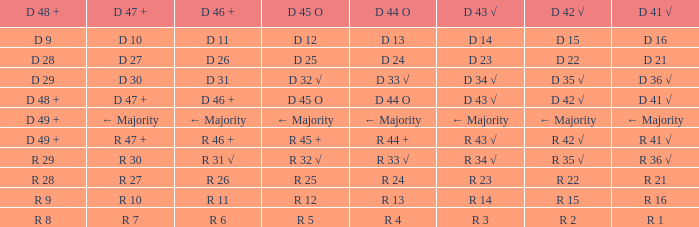What is the significance of d 47 + when the significance of d 44 o is r 24? R 27. 